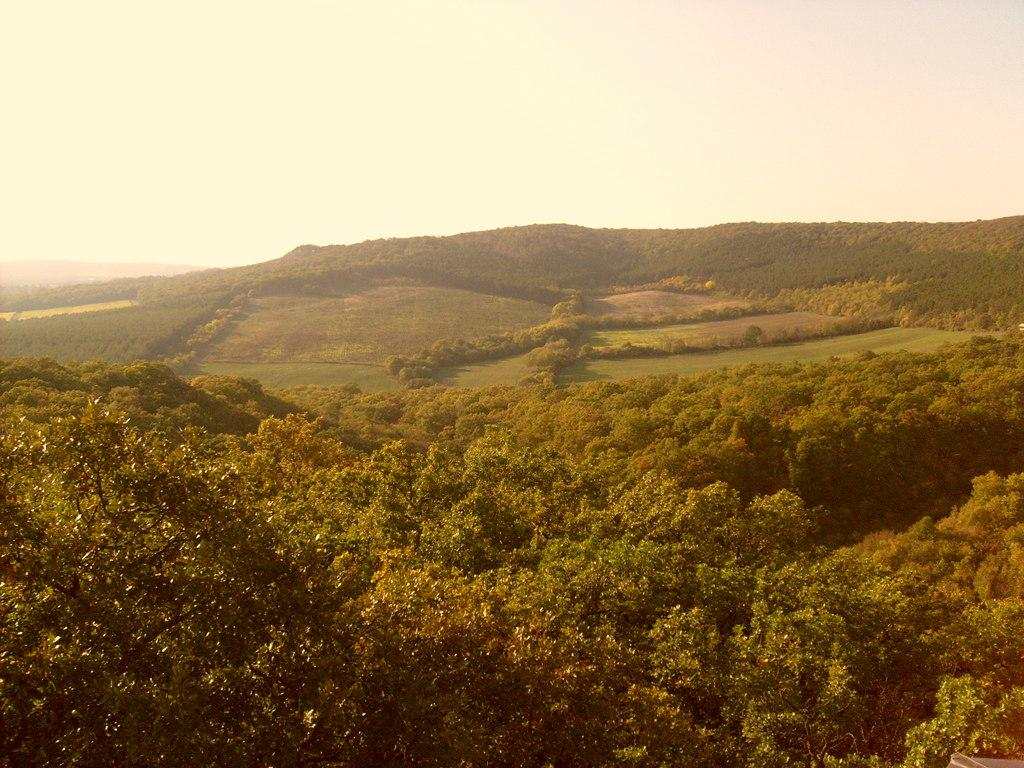What type of image is depicted in the picture? The image appears to be a scenery. What can be seen at the bottom of the image? There are trees at the bottom of the image. What is visible in the background of the image? There are hills in the background of the image. What is visible at the top of the image? The sky is visible at the top of the image. Can you see the mother walking her dog in the image? There is no mother or dog present in the image. How many ladybugs are crawling on the trees in the image? There are no ladybugs visible in the image. 